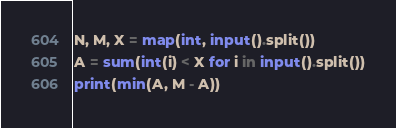<code> <loc_0><loc_0><loc_500><loc_500><_Python_>N, M, X = map(int, input().split())
A = sum(int(i) < X for i in input().split())
print(min(A, M - A))</code> 